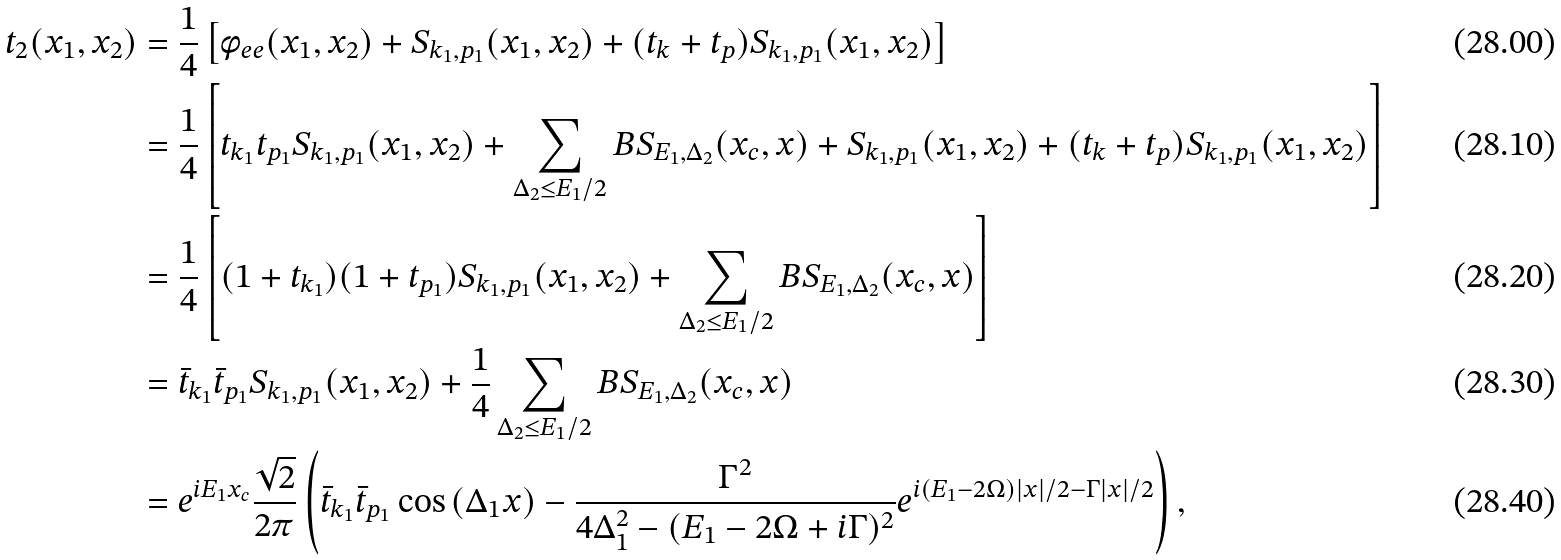Convert formula to latex. <formula><loc_0><loc_0><loc_500><loc_500>t _ { 2 } ( x _ { 1 } , x _ { 2 } ) & = \frac { 1 } { 4 } \left [ \phi _ { e e } ( x _ { 1 } , x _ { 2 } ) + S _ { k _ { 1 } , p _ { 1 } } ( x _ { 1 } , x _ { 2 } ) + ( t _ { k } + t _ { p } ) S _ { k _ { 1 } , p _ { 1 } } ( x _ { 1 } , x _ { 2 } ) \right ] \\ & = \frac { 1 } { 4 } \left [ t _ { k _ { 1 } } t _ { p _ { 1 } } S _ { k _ { 1 } , p _ { 1 } } ( x _ { 1 } , x _ { 2 } ) + \sum _ { \Delta _ { 2 } \leq E _ { 1 } / 2 } B S _ { E _ { 1 } , \Delta _ { 2 } } ( x _ { c } , x ) + S _ { k _ { 1 } , p _ { 1 } } ( x _ { 1 } , x _ { 2 } ) + ( t _ { k } + t _ { p } ) S _ { k _ { 1 } , p _ { 1 } } ( x _ { 1 } , x _ { 2 } ) \right ] \\ & = \frac { 1 } { 4 } \left [ ( 1 + t _ { k _ { 1 } } ) ( 1 + t _ { p _ { 1 } } ) S _ { k _ { 1 } , p _ { 1 } } ( x _ { 1 } , x _ { 2 } ) + \sum _ { \Delta _ { 2 } \leq E _ { 1 } / 2 } B S _ { E _ { 1 } , \Delta _ { 2 } } ( x _ { c } , x ) \right ] \\ & = \bar { t } _ { k _ { 1 } } \bar { t } _ { p _ { 1 } } S _ { k _ { 1 } , p _ { 1 } } ( x _ { 1 } , x _ { 2 } ) + \frac { 1 } { 4 } \sum _ { \Delta _ { 2 } \leq E _ { 1 } / 2 } B S _ { E _ { 1 } , \Delta _ { 2 } } ( x _ { c } , x ) \\ & = e ^ { i E _ { 1 } x _ { c } } \frac { \sqrt { 2 } } { 2 \pi } \left ( \bar { t } _ { k _ { 1 } } \bar { t } _ { p _ { 1 } } \cos \left ( \Delta _ { 1 } x \right ) - \frac { \Gamma ^ { 2 } } { 4 \Delta _ { 1 } ^ { 2 } - ( E _ { 1 } - 2 \Omega + i \Gamma ) ^ { 2 } } e ^ { i ( E _ { 1 } - 2 \Omega ) | x | / 2 - \Gamma | x | / 2 } \right ) ,</formula> 